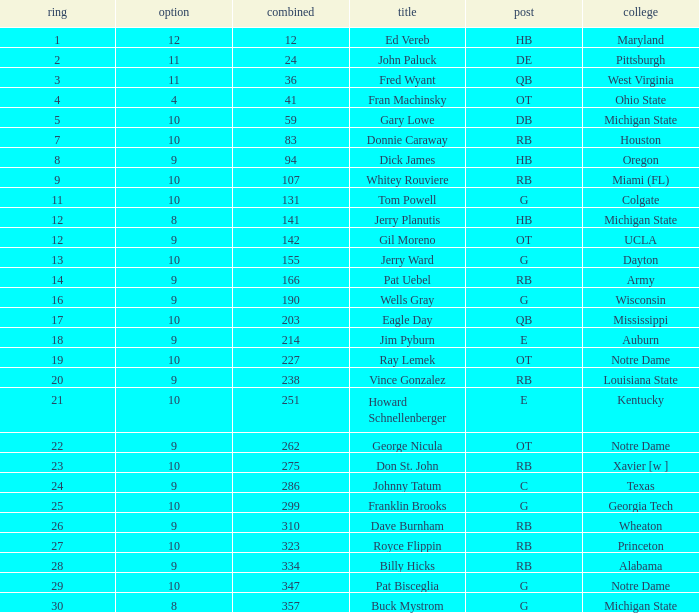Help me parse the entirety of this table. {'header': ['ring', 'option', 'combined', 'title', 'post', 'college'], 'rows': [['1', '12', '12', 'Ed Vereb', 'HB', 'Maryland'], ['2', '11', '24', 'John Paluck', 'DE', 'Pittsburgh'], ['3', '11', '36', 'Fred Wyant', 'QB', 'West Virginia'], ['4', '4', '41', 'Fran Machinsky', 'OT', 'Ohio State'], ['5', '10', '59', 'Gary Lowe', 'DB', 'Michigan State'], ['7', '10', '83', 'Donnie Caraway', 'RB', 'Houston'], ['8', '9', '94', 'Dick James', 'HB', 'Oregon'], ['9', '10', '107', 'Whitey Rouviere', 'RB', 'Miami (FL)'], ['11', '10', '131', 'Tom Powell', 'G', 'Colgate'], ['12', '8', '141', 'Jerry Planutis', 'HB', 'Michigan State'], ['12', '9', '142', 'Gil Moreno', 'OT', 'UCLA'], ['13', '10', '155', 'Jerry Ward', 'G', 'Dayton'], ['14', '9', '166', 'Pat Uebel', 'RB', 'Army'], ['16', '9', '190', 'Wells Gray', 'G', 'Wisconsin'], ['17', '10', '203', 'Eagle Day', 'QB', 'Mississippi'], ['18', '9', '214', 'Jim Pyburn', 'E', 'Auburn'], ['19', '10', '227', 'Ray Lemek', 'OT', 'Notre Dame'], ['20', '9', '238', 'Vince Gonzalez', 'RB', 'Louisiana State'], ['21', '10', '251', 'Howard Schnellenberger', 'E', 'Kentucky'], ['22', '9', '262', 'George Nicula', 'OT', 'Notre Dame'], ['23', '10', '275', 'Don St. John', 'RB', 'Xavier [w ]'], ['24', '9', '286', 'Johnny Tatum', 'C', 'Texas'], ['25', '10', '299', 'Franklin Brooks', 'G', 'Georgia Tech'], ['26', '9', '310', 'Dave Burnham', 'RB', 'Wheaton'], ['27', '10', '323', 'Royce Flippin', 'RB', 'Princeton'], ['28', '9', '334', 'Billy Hicks', 'RB', 'Alabama'], ['29', '10', '347', 'Pat Bisceglia', 'G', 'Notre Dame'], ['30', '8', '357', 'Buck Mystrom', 'G', 'Michigan State']]} What is the sum of rounds that has a pick of 9 and is named jim pyburn? 18.0. 